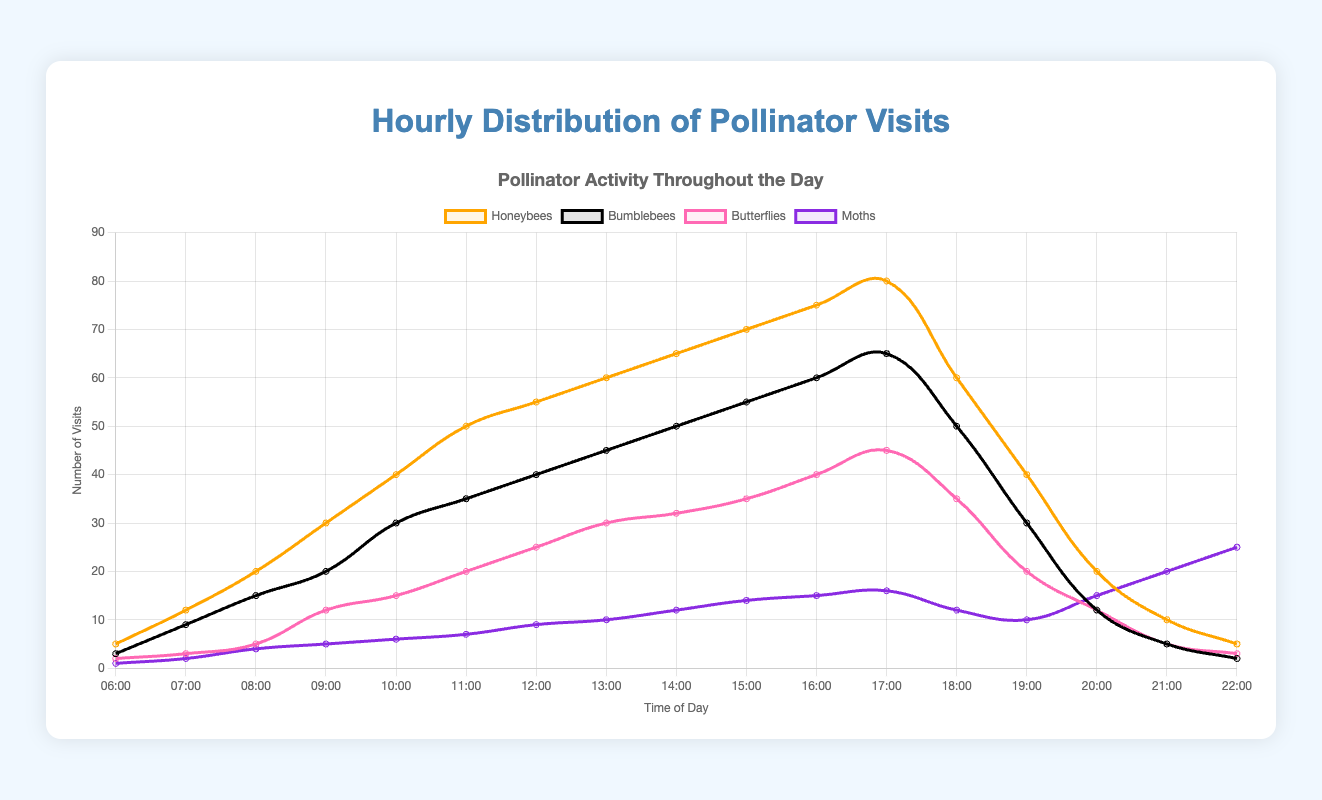What time has the peak number of honeybee visits? Looking at the graph, find the point where the Honeybees line reaches its maximum value. This peak occurs at 17:00.
Answer: 17:00 How does the number of moth visits at 21:00 compare to honeybee visits? Observe the values at 21:00 on the graph. Moth visits are higher, with moths at 20 visits and honeybees at 10 visits.
Answer: Moths have more visits What is the total number of butterfly visits between 12:00 and 14:00? Sum the butterfly visits at 12:00, 13:00, and 14:00. At these times, the numbers are 25, 30, and 32 respectively, summing up to 87.
Answer: 87 At what time do bumblebee visits first reach 60? Find when the Bumblebees line first hits 60 on the y-axis. This occurs at 16:00.
Answer: 16:00 How do bumblebee and honeybee visits compare at 08:00? Check the values for both lines at 08:00. Bumblebees have 15 visits, and honeybees have 20 visits, so honeybees have more.
Answer: Honeybees have more visits Which pollinator has the highest visits at 22:00? Examine the highest point among all lines at 22:00. Moths have 25 visits, which is the highest.
Answer: Moths What's the average number of honeybee visits between 10:00 and 12:00? Calculate the average of honeybee visits at 10:00, 11:00, and 12:00. The values are 40, 50, and 55 respectively. The sum is 145, and the average is 145/3 which is approximately 48.33.
Answer: 48.33 Compare butterfly visits at 13:00 versus moth visits at 20:00. Look at the graph to find the values. Butterflies at 13:00 have 30 visits, while moths at 20:00 have 15 visits. Butterflies have more visits.
Answer: Butterflies have more visits What time has the lowest number of moth visits? Identify the lowest point of the Moths line, which occurs at 06:00 with 1 visit.
Answer: 06:00 What is the difference in visits between honeybees and bumblebees at 18:00? Subtract the number of bumblebee visits from honeybee visits at 18:00. Honeybees have 60 visits and bumblebees have 50, so the difference is 10.
Answer: 10 